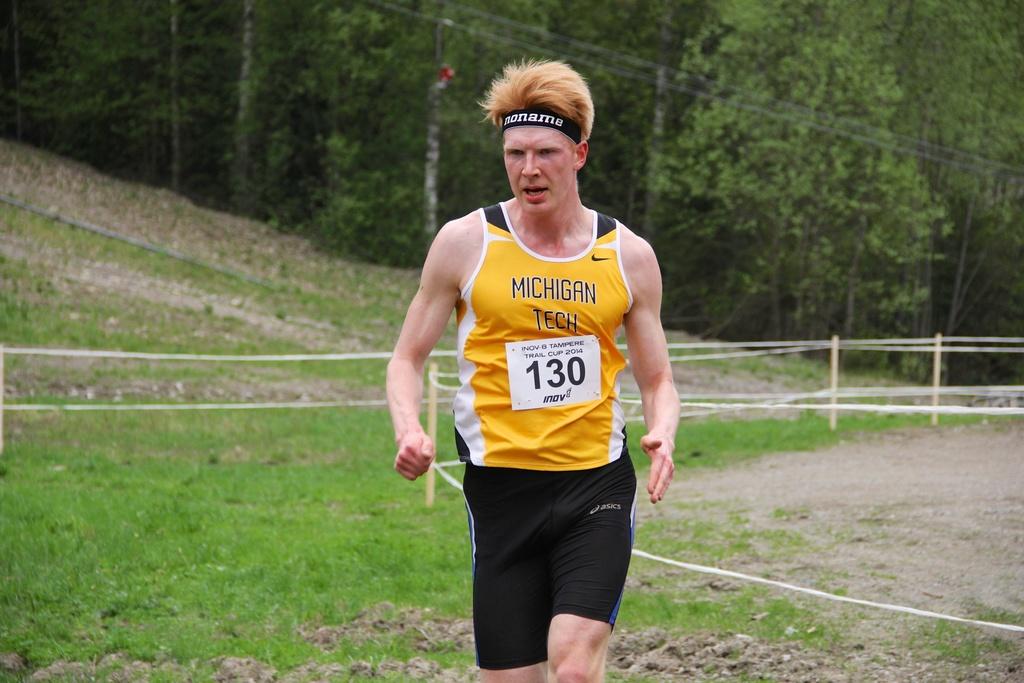What state is on the man's shirt?
Your answer should be very brief. Michigan. 